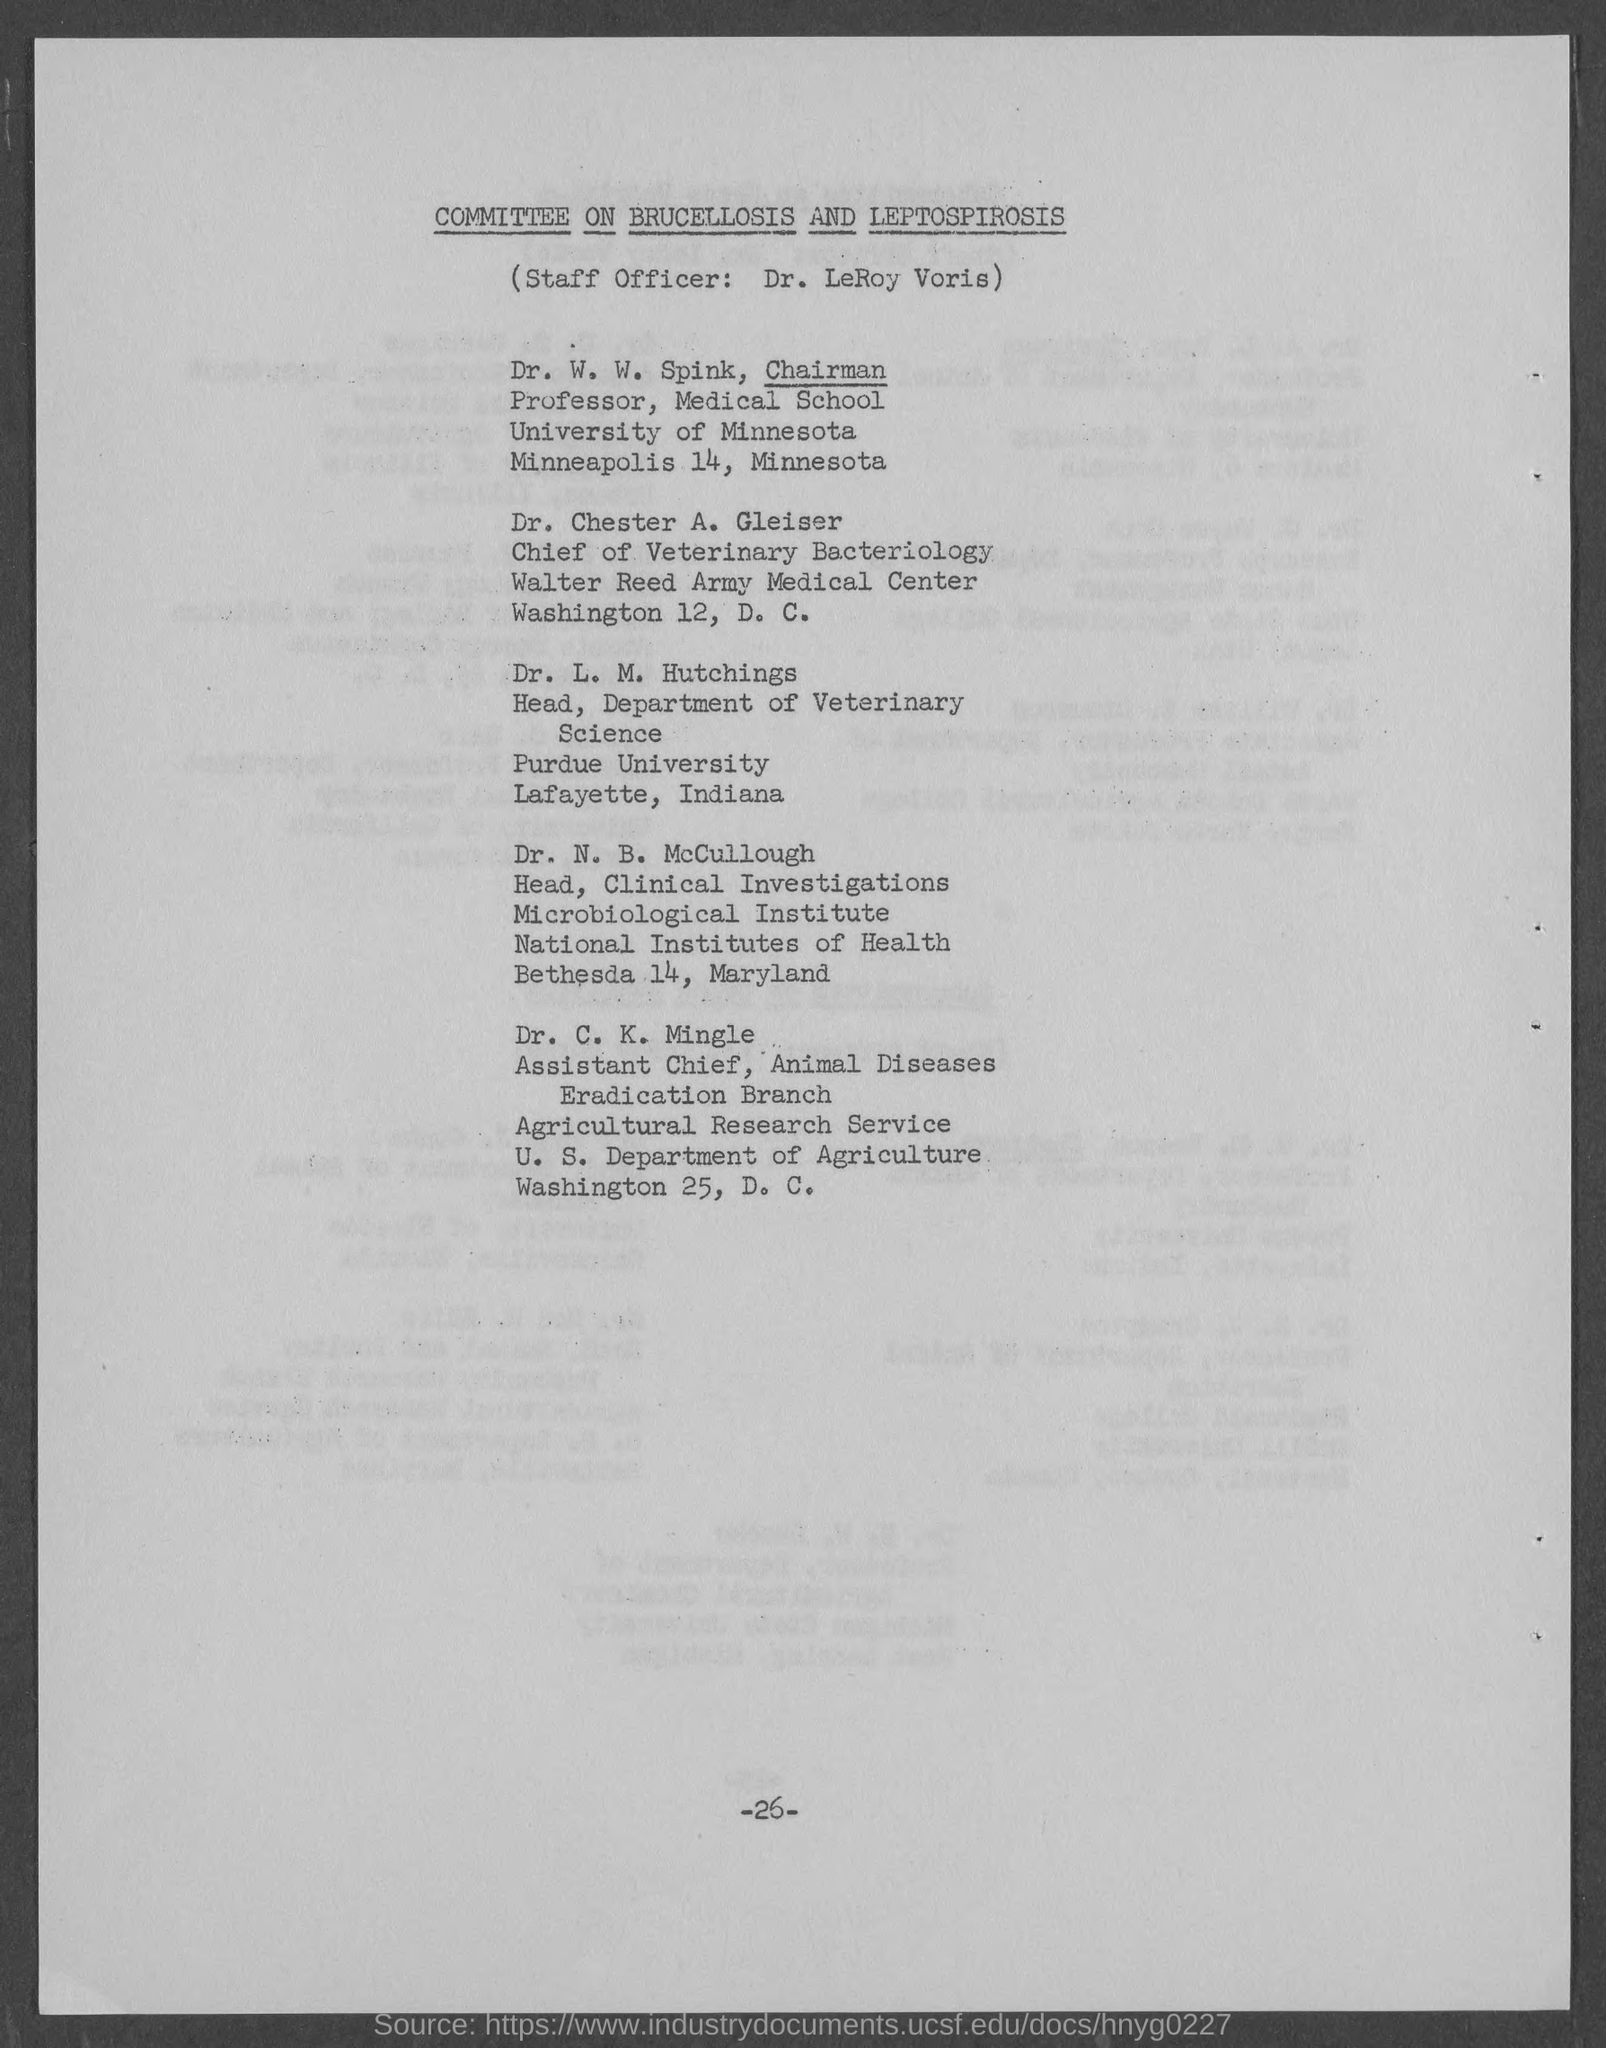Give some essential details in this illustration. The page number on this document is -26-. The identity of the Chairman is Dr. W. W. Spink. The head of the Department of Veterinary Science is Dr. L. M. Hutchings. It is Dr. LeRoy Voris who is the staff officer. The document title is "The Committee on Brucellosis and Leptospirosis. 